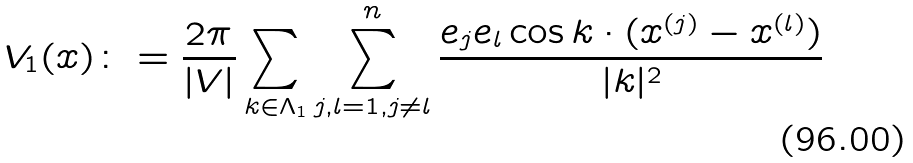<formula> <loc_0><loc_0><loc_500><loc_500>V _ { 1 } ( x ) \colon = \frac { 2 \pi } { | V | } \sum _ { k \in \Lambda _ { 1 } } \sum _ { j , l = 1 , j \not = l } ^ { n } \frac { e _ { j } e _ { l } \cos k \cdot ( x ^ { ( j ) } - x ^ { ( l ) } ) } { | k | ^ { 2 } }</formula> 